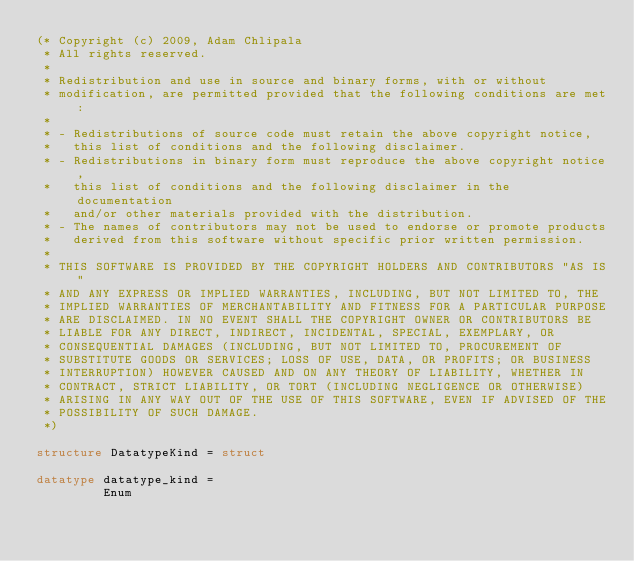<code> <loc_0><loc_0><loc_500><loc_500><_SML_>(* Copyright (c) 2009, Adam Chlipala
 * All rights reserved.
 *
 * Redistribution and use in source and binary forms, with or without
 * modification, are permitted provided that the following conditions are met:
 *
 * - Redistributions of source code must retain the above copyright notice,
 *   this list of conditions and the following disclaimer.
 * - Redistributions in binary form must reproduce the above copyright notice,
 *   this list of conditions and the following disclaimer in the documentation
 *   and/or other materials provided with the distribution.
 * - The names of contributors may not be used to endorse or promote products
 *   derived from this software without specific prior written permission.
 *
 * THIS SOFTWARE IS PROVIDED BY THE COPYRIGHT HOLDERS AND CONTRIBUTORS "AS IS"
 * AND ANY EXPRESS OR IMPLIED WARRANTIES, INCLUDING, BUT NOT LIMITED TO, THE
 * IMPLIED WARRANTIES OF MERCHANTABILITY AND FITNESS FOR A PARTICULAR PURPOSE
 * ARE DISCLAIMED. IN NO EVENT SHALL THE COPYRIGHT OWNER OR CONTRIBUTORS BE
 * LIABLE FOR ANY DIRECT, INDIRECT, INCIDENTAL, SPECIAL, EXEMPLARY, OR 
 * CONSEQUENTIAL DAMAGES (INCLUDING, BUT NOT LIMITED TO, PROCUREMENT OF
 * SUBSTITUTE GOODS OR SERVICES; LOSS OF USE, DATA, OR PROFITS; OR BUSINESS
 * INTERRUPTION) HOWEVER CAUSED AND ON ANY THEORY OF LIABILITY, WHETHER IN
 * CONTRACT, STRICT LIABILITY, OR TORT (INCLUDING NEGLIGENCE OR OTHERWISE)
 * ARISING IN ANY WAY OUT OF THE USE OF THIS SOFTWARE, EVEN IF ADVISED OF THE
 * POSSIBILITY OF SUCH DAMAGE.
 *)

structure DatatypeKind = struct

datatype datatype_kind =
         Enum</code> 